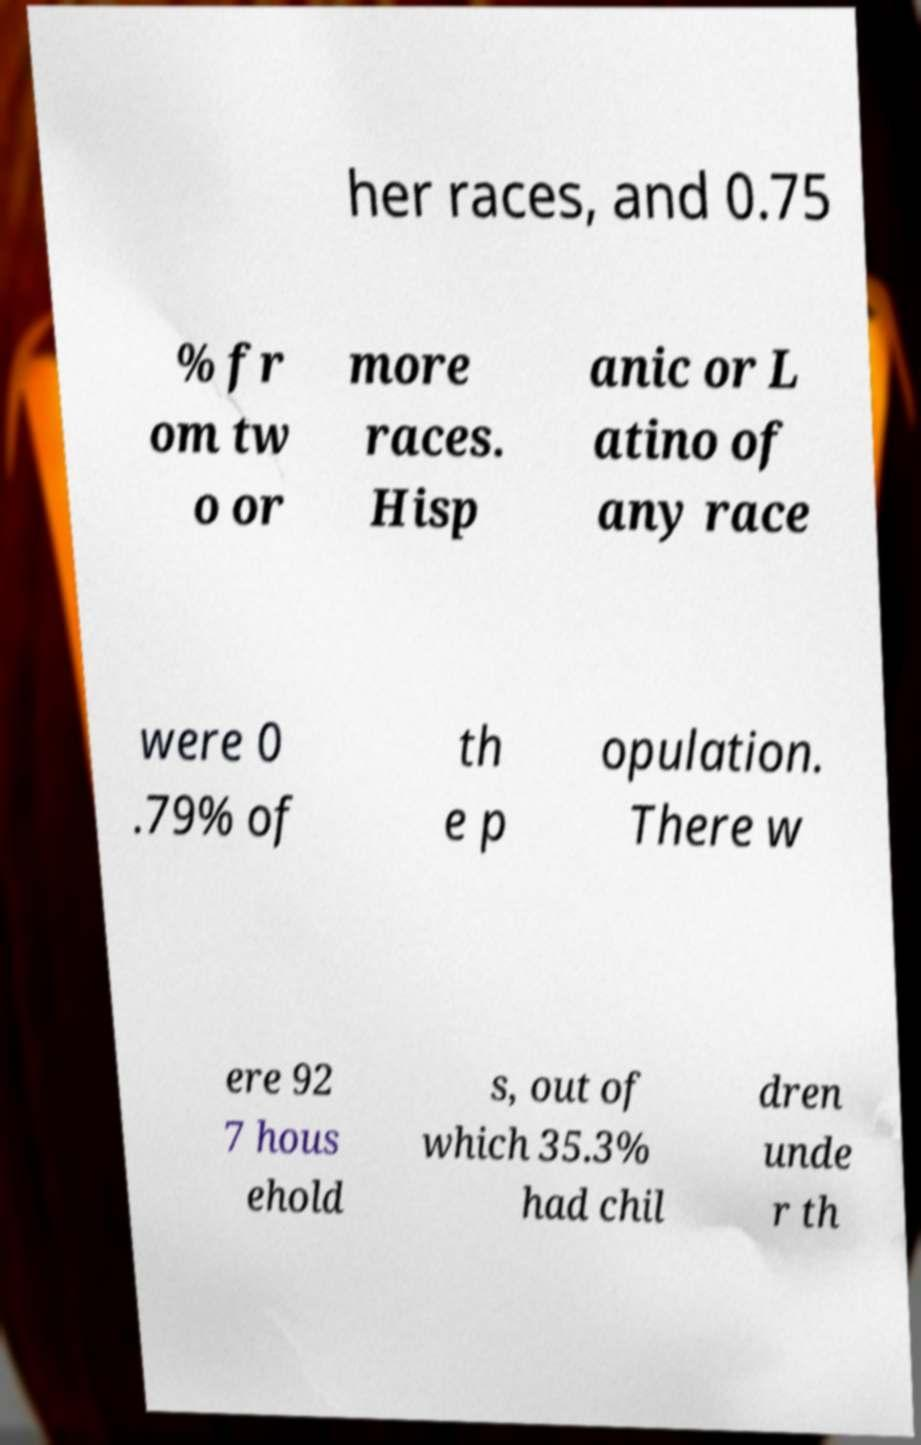Can you accurately transcribe the text from the provided image for me? her races, and 0.75 % fr om tw o or more races. Hisp anic or L atino of any race were 0 .79% of th e p opulation. There w ere 92 7 hous ehold s, out of which 35.3% had chil dren unde r th 